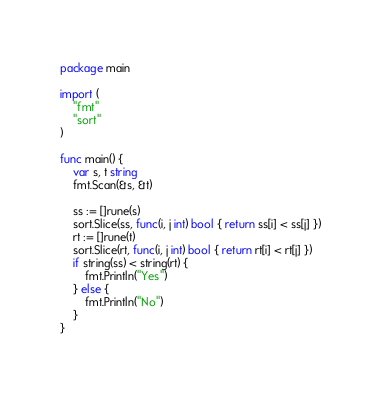Convert code to text. <code><loc_0><loc_0><loc_500><loc_500><_Go_>package main

import (
	"fmt"
	"sort"
)

func main() {
	var s, t string
	fmt.Scan(&s, &t)

	ss := []rune(s)
	sort.Slice(ss, func(i, j int) bool { return ss[i] < ss[j] })
	rt := []rune(t)
	sort.Slice(rt, func(i, j int) bool { return rt[i] < rt[j] })
	if string(ss) < string(rt) {
		fmt.Println("Yes")
	} else {
		fmt.Println("No")
	}
}
</code> 